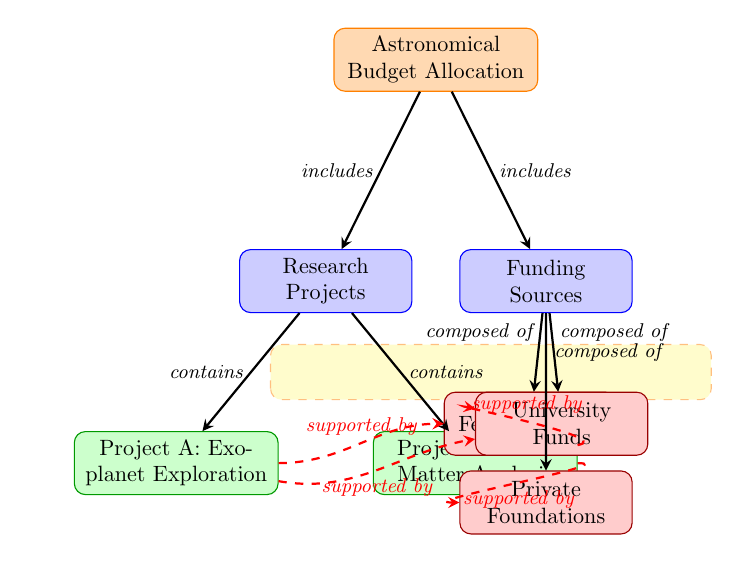What are the two research projects listed? The diagram shows two projects under the "Research Projects" category: Project A and Project B. These are labeled directly within the diagram.
Answer: Exoplanet Exploration, Dark Matter Analysis How many funding sources are identified? The diagram includes three funding sources listed under the "Funding Sources" category: Federal Grants, Private Foundations, and University Funds. The count can be directly seen from the nodes present.
Answer: 3 Which project is supported by Federal Grants? The diagram indicates that Project A is directly connected to Federal Grants through a dashed arrow labeled "supported by." This shows the funding source for that project.
Answer: Project A: Exoplanet Exploration What is the relationship between the projects and funding sources? The projects are encompassed by arrows leading to the "Funding Sources" category, suggesting that they receive support from these funding sources. Each project has connections to specific funding sources indicated by the dashed arrows connecting them.
Answer: Supported by Which project has support from Private Foundations? The connection in the diagram illustrates that Project B is supported by Private Foundations, indicated by the dashed arrow labeled "supported by." This direct relationship shows which funding source applies.
Answer: Project B: Dark Matter Analysis How does Project A receive funding from University Funds? The diagram shows a dashed arrow that connects Project A to University Funds, indicating that Project A receives some support from this funding source in addition to Federal Grants. This shows overlapping funding avenues for the project.
Answer: Supported by University Funds 